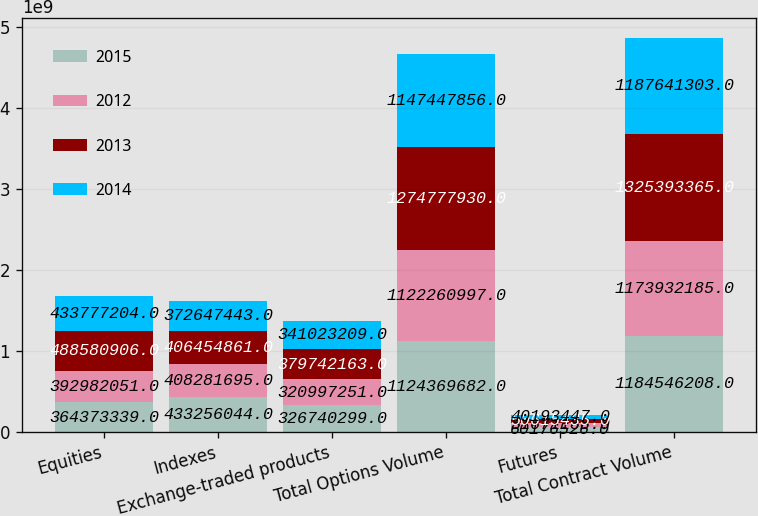Convert chart to OTSL. <chart><loc_0><loc_0><loc_500><loc_500><stacked_bar_chart><ecel><fcel>Equities<fcel>Indexes<fcel>Exchange-traded products<fcel>Total Options Volume<fcel>Futures<fcel>Total Contract Volume<nl><fcel>2015<fcel>3.64373e+08<fcel>4.33256e+08<fcel>3.2674e+08<fcel>1.12437e+09<fcel>6.01765e+07<fcel>1.18455e+09<nl><fcel>2012<fcel>3.92982e+08<fcel>4.08282e+08<fcel>3.20997e+08<fcel>1.12226e+09<fcel>5.16712e+07<fcel>1.17393e+09<nl><fcel>2013<fcel>4.88581e+08<fcel>4.06455e+08<fcel>3.79742e+08<fcel>1.27478e+09<fcel>5.06154e+07<fcel>1.32539e+09<nl><fcel>2014<fcel>4.33777e+08<fcel>3.72647e+08<fcel>3.41023e+08<fcel>1.14745e+09<fcel>4.01934e+07<fcel>1.18764e+09<nl></chart> 